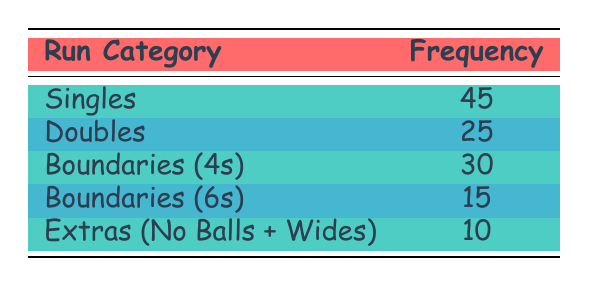What's the frequency of Singles? The table clearly shows that the frequency associated with the category "Singles" is 45.
Answer: 45 What is the total frequency of all run categories? To find the total frequency, we add up the frequencies of all categories: 45 (Singles) + 25 (Doubles) + 30 (Boundaries 4s) + 15 (Boundaries 6s) + 10 (Extras) = 125.
Answer: 125 Does the frequency of Extras exceed 5? The frequency of Extras is 10, which is greater than 5. Therefore, the statement is true.
Answer: Yes Which category has the highest frequency? By comparing the frequencies in the table, "Singles" has the highest frequency of 45.
Answer: Singles What is the average frequency of Boundaries? Boundaries consist of both 4s and 6s, which have frequencies of 30 and 15 respectively. To find the average, sum the frequencies (30 + 15 = 45) and divide by the number of categories (2): 45 / 2 = 22.5.
Answer: 22.5 Is the frequency of Doubles less than the frequency of Boundaries (4s)? The frequency of Doubles is 25 and that of Boundaries (4s) is 30. Since 25 is less than 30, the statement is true.
Answer: Yes What is the difference in frequency between Boundaries (4s) and Boundaries (6s)? The frequency of Boundaries (4s) is 30 and for Boundaries (6s) it is 15. The difference is 30 - 15 = 15.
Answer: 15 How many more Singles are scored compared to Extras? The frequency of Singles is 45 and that of Extras is 10. The difference is 45 - 10 = 35.
Answer: 35 What percentage of the total frequency is made up of Doubles? The total frequency is 125. The frequency of Doubles is 25. The percentage is calculated as (25 / 125) * 100 = 20%.
Answer: 20% 